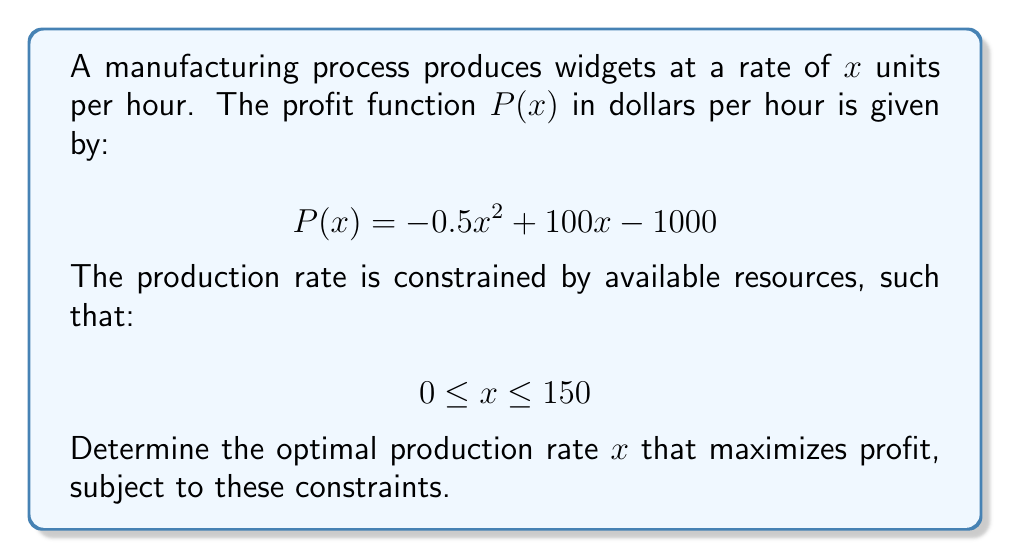Solve this math problem. To solve this optimization problem, we'll follow these steps:

1) First, we need to find the unconstrained maximum of the profit function. We can do this by differentiating $P(x)$ and setting it to zero:

   $$\frac{dP}{dx} = -x + 100 = 0$$
   $$x = 100$$

2) The second derivative is negative ($\frac{d^2P}{dx^2} = -1 < 0$), confirming this is a maximum.

3) Now we need to check if this unconstrained maximum satisfies our constraints:

   $$0 \leq x \leq 150$$

   Indeed, 100 is within this range.

4) Therefore, the constrained maximum occurs at the same point as the unconstrained maximum.

5) To verify, we can calculate the profit at $x = 100$:

   $$P(100) = -0.5(100)^2 + 100(100) - 1000 = 4000$$

   This is indeed greater than the profit at the endpoints of our constraint:

   $$P(0) = -1000$$
   $$P(150) = -0.5(150)^2 + 100(150) - 1000 = 2750$$

Thus, the optimal production rate that maximizes profit while satisfying the resource constraints is 100 units per hour.
Answer: $x = 100$ units per hour 